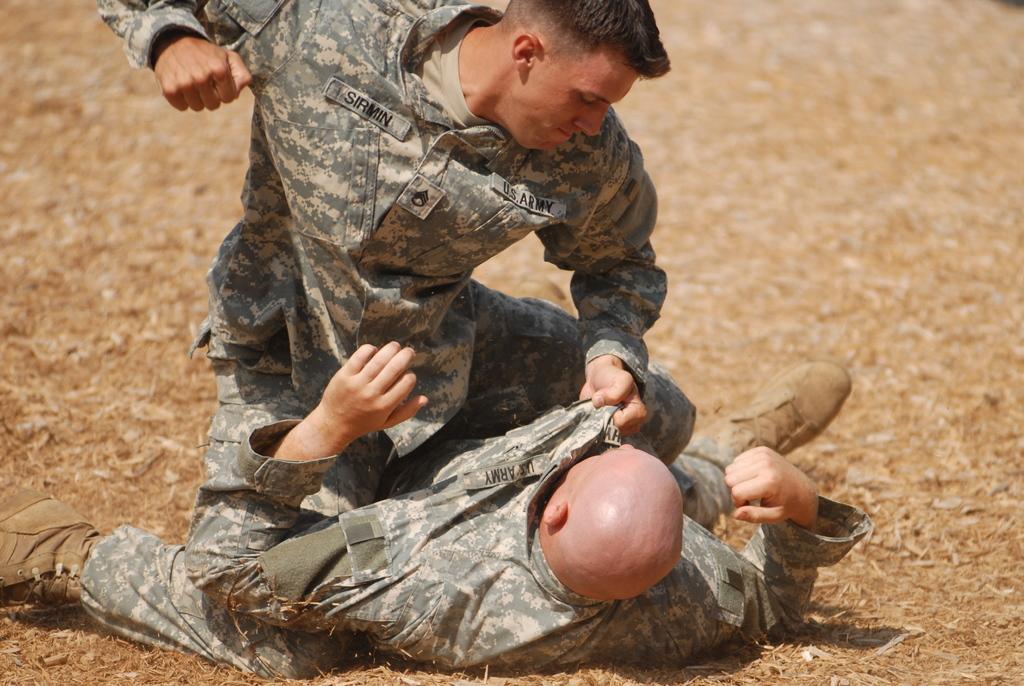In one or two sentences, can you explain what this image depicts? In this image I can see two people with military dresses. I can see one person lying on the ground and another one sitting on him. In the background I can see the brown color ground. 